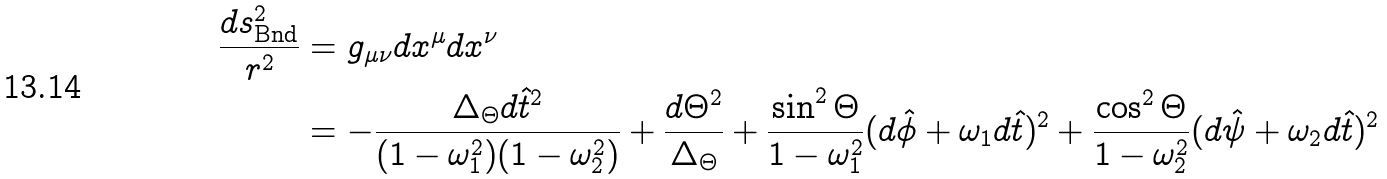<formula> <loc_0><loc_0><loc_500><loc_500>\frac { d s ^ { 2 } _ { \text {Bnd} } } { r ^ { 2 } } & = g _ { \mu \nu } d x ^ { \mu } d x ^ { \nu } \\ & = - \frac { \Delta _ { \Theta } d \hat { t } ^ { 2 } } { ( 1 - \omega _ { 1 } ^ { 2 } ) ( 1 - \omega _ { 2 } ^ { 2 } ) } + \frac { d \Theta ^ { 2 } } { \Delta _ { \Theta } } + \frac { \sin ^ { 2 } \Theta } { 1 - \omega _ { 1 } ^ { 2 } } ( d \hat { \phi } + \omega _ { 1 } d \hat { t } ) ^ { 2 } + \frac { \cos ^ { 2 } \Theta } { 1 - \omega _ { 2 } ^ { 2 } } ( d \hat { \psi } + \omega _ { 2 } d \hat { t } ) ^ { 2 } \\</formula> 